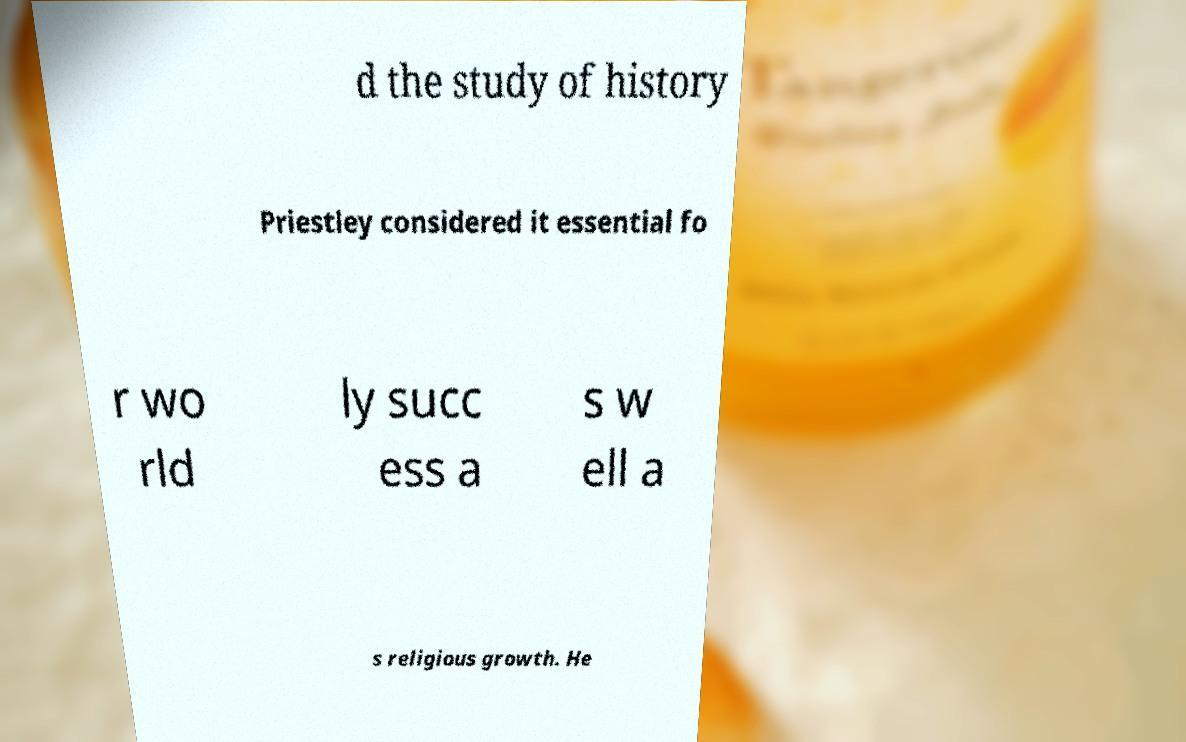There's text embedded in this image that I need extracted. Can you transcribe it verbatim? d the study of history Priestley considered it essential fo r wo rld ly succ ess a s w ell a s religious growth. He 